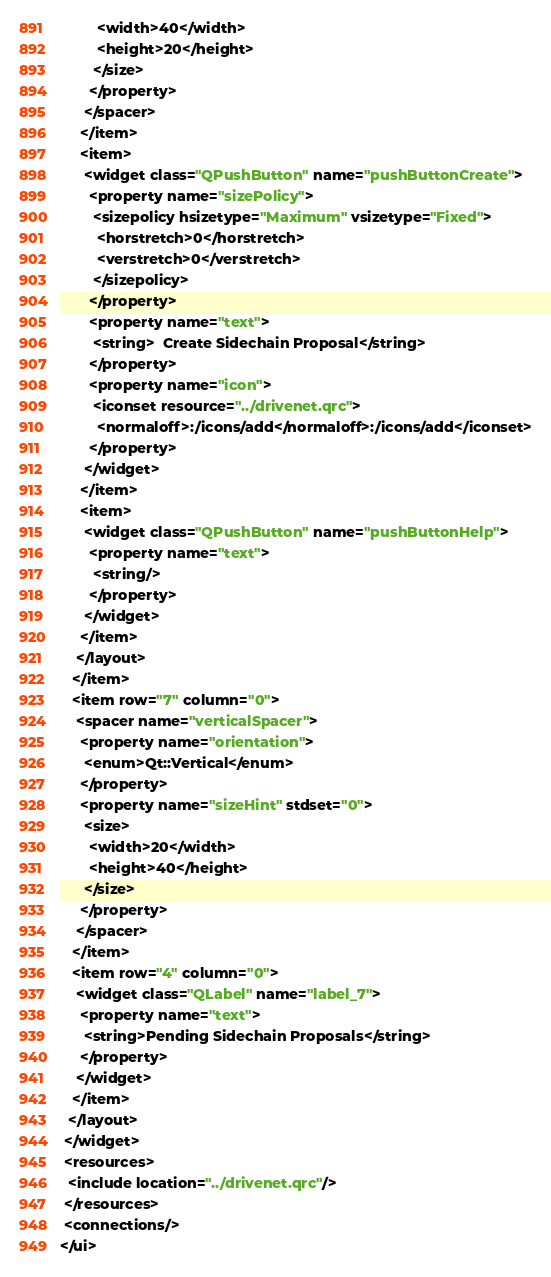Convert code to text. <code><loc_0><loc_0><loc_500><loc_500><_XML_>         <width>40</width>
         <height>20</height>
        </size>
       </property>
      </spacer>
     </item>
     <item>
      <widget class="QPushButton" name="pushButtonCreate">
       <property name="sizePolicy">
        <sizepolicy hsizetype="Maximum" vsizetype="Fixed">
         <horstretch>0</horstretch>
         <verstretch>0</verstretch>
        </sizepolicy>
       </property>
       <property name="text">
        <string>  Create Sidechain Proposal</string>
       </property>
       <property name="icon">
        <iconset resource="../drivenet.qrc">
         <normaloff>:/icons/add</normaloff>:/icons/add</iconset>
       </property>
      </widget>
     </item>
     <item>
      <widget class="QPushButton" name="pushButtonHelp">
       <property name="text">
        <string/>
       </property>
      </widget>
     </item>
    </layout>
   </item>
   <item row="7" column="0">
    <spacer name="verticalSpacer">
     <property name="orientation">
      <enum>Qt::Vertical</enum>
     </property>
     <property name="sizeHint" stdset="0">
      <size>
       <width>20</width>
       <height>40</height>
      </size>
     </property>
    </spacer>
   </item>
   <item row="4" column="0">
    <widget class="QLabel" name="label_7">
     <property name="text">
      <string>Pending Sidechain Proposals</string>
     </property>
    </widget>
   </item>
  </layout>
 </widget>
 <resources>
  <include location="../drivenet.qrc"/>
 </resources>
 <connections/>
</ui>
</code> 